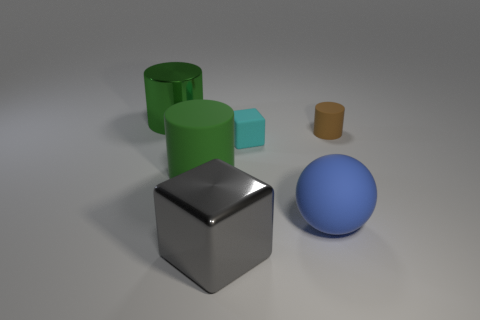Is there any other thing that has the same material as the large gray object?
Your response must be concise. Yes. There is a green thing that is to the right of the large object that is behind the cylinder on the right side of the gray metal object; what is it made of?
Offer a terse response. Rubber. There is another large cylinder that is the same color as the big rubber cylinder; what is its material?
Offer a very short reply. Metal. What number of big green cylinders have the same material as the cyan block?
Ensure brevity in your answer.  1. There is a green object in front of the brown rubber cylinder; does it have the same size as the blue sphere?
Keep it short and to the point. Yes. What is the color of the other big object that is the same material as the blue object?
Provide a short and direct response. Green. Is there anything else that is the same size as the blue thing?
Keep it short and to the point. Yes. There is a cyan block; what number of small cyan rubber blocks are on the left side of it?
Make the answer very short. 0. Does the large cylinder that is on the right side of the green metallic thing have the same color as the metal object that is in front of the small rubber cylinder?
Your response must be concise. No. What color is the other matte thing that is the same shape as the big gray thing?
Provide a succinct answer. Cyan. 